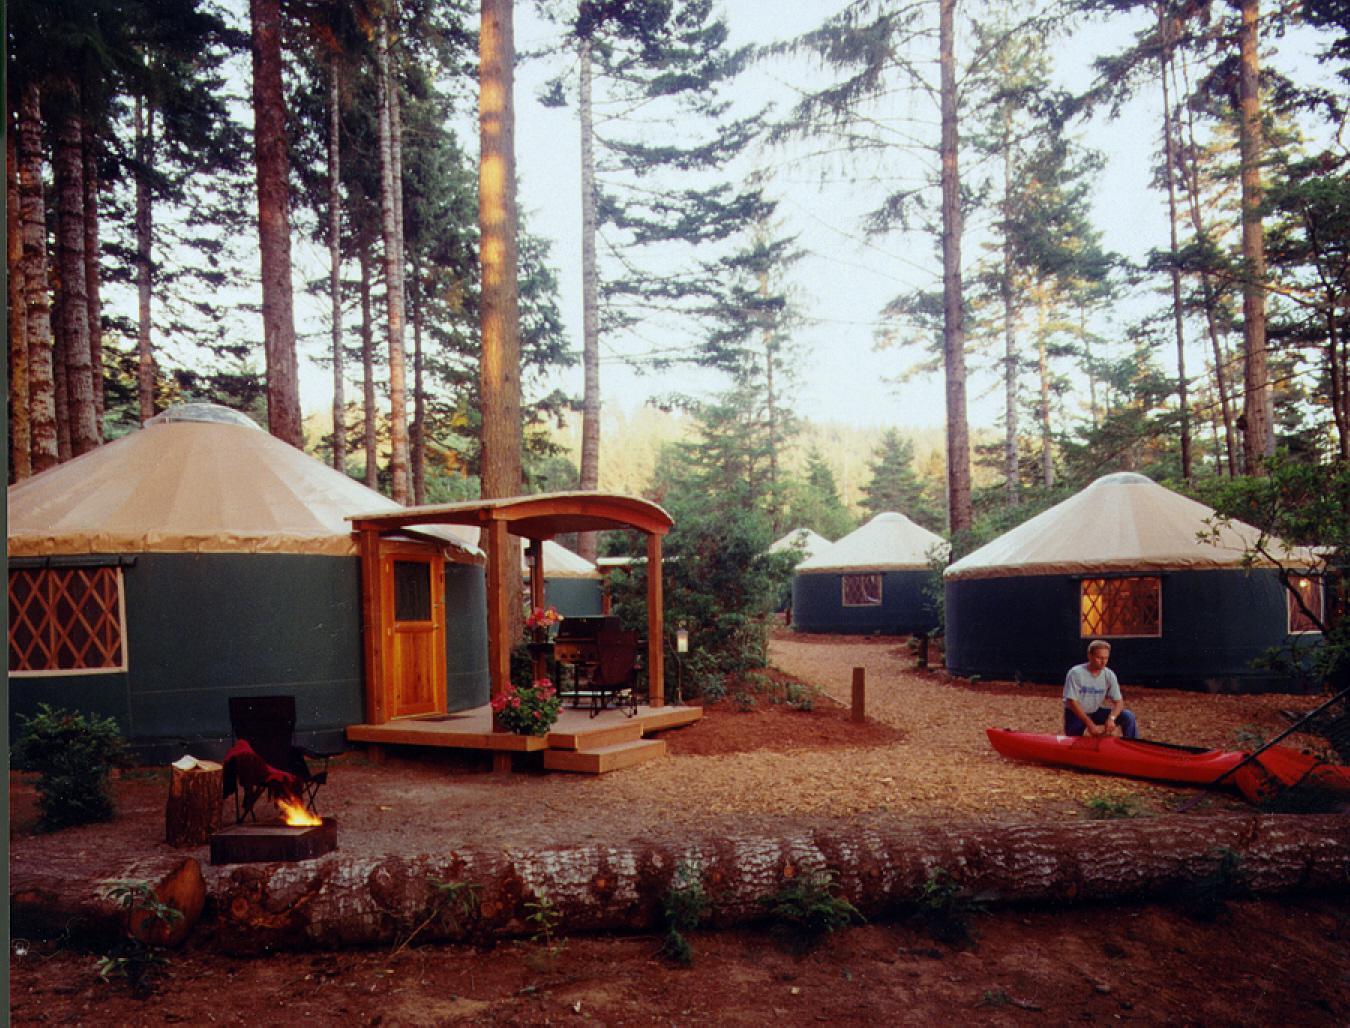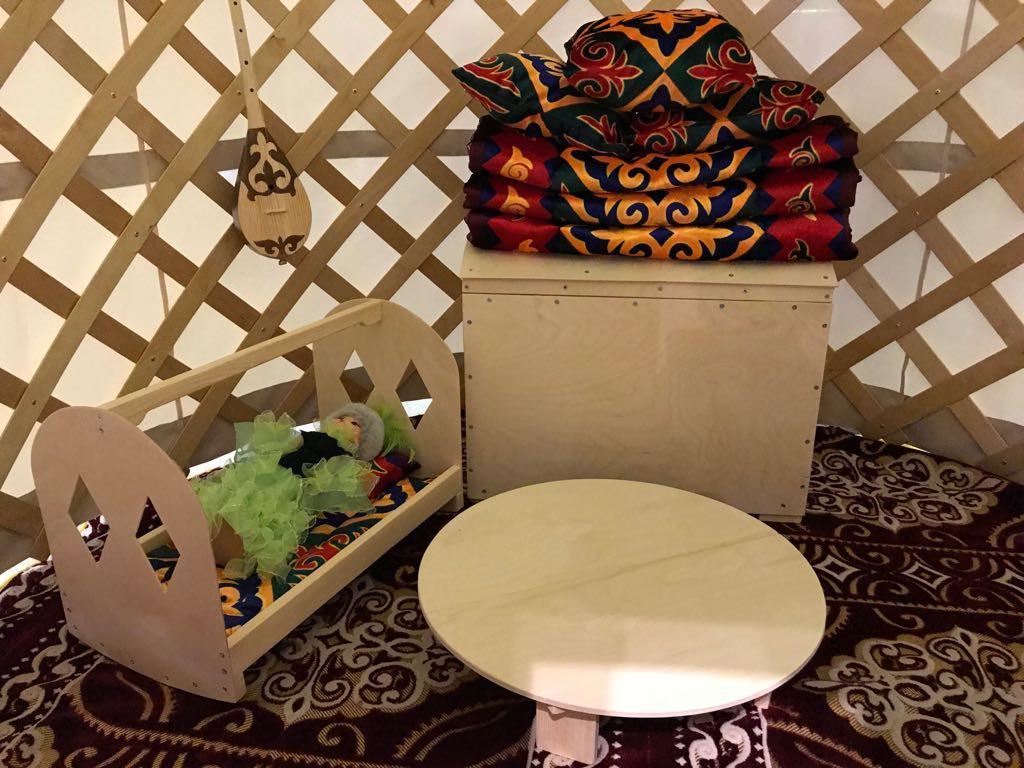The first image is the image on the left, the second image is the image on the right. For the images displayed, is the sentence "One image is an interior with lattice on the walls, and the other is an exterior shot of round buildings with a tall tree present." factually correct? Answer yes or no. Yes. The first image is the image on the left, the second image is the image on the right. Analyze the images presented: Is the assertion "In one image, at least four yurts are seen in an outdoor area with at least one tree, while a second image shows the interior of a yurt with lattice on wall area." valid? Answer yes or no. Yes. 